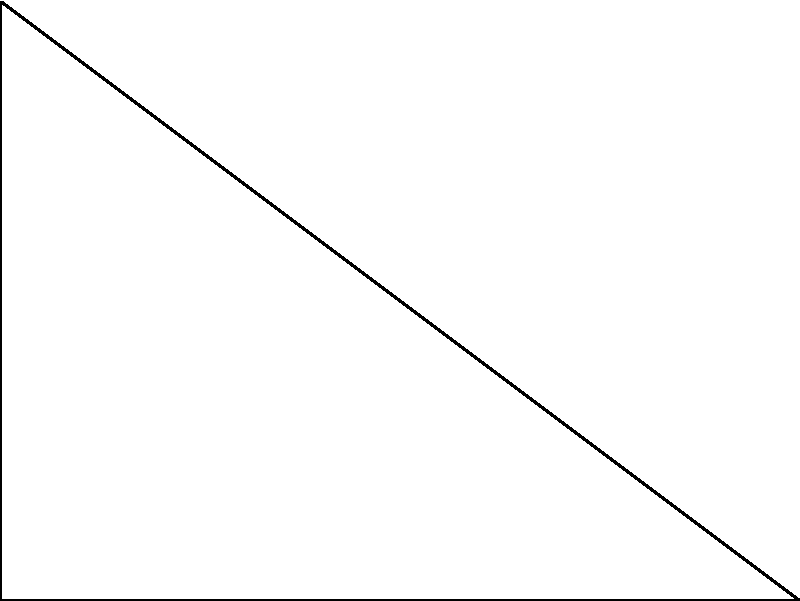During Hanukkah in Lisbon, Portugal (latitude 38.7° N), the solar elevation angle at noon is observed to be 28.5°. Given that the height of a building casts a shadow 15 meters long at this time, calculate the height of the building. To solve this problem, we'll use trigonometry and the given information about the solar elevation angle and shadow length. Let's approach this step-by-step:

1) First, let's identify the known variables:
   - Solar elevation angle (θ) = 28.5°
   - Shadow length (L) = 15 meters
   - We need to find the height of the building (H)

2) In the right-angled triangle formed by the building, its shadow, and the sun's rays:
   - The shadow length forms the adjacent side to the angle θ
   - The building height forms the opposite side to the angle θ

3) We can use the tangent trigonometric function, which is defined as:

   $$ \tan(\theta) = \frac{\text{opposite}}{\text{adjacent}} = \frac{\text{height}}{\text{shadow length}} $$

4) Substituting our known values:

   $$ \tan(28.5°) = \frac{H}{15} $$

5) To solve for H, multiply both sides by 15:

   $$ 15 \cdot \tan(28.5°) = H $$

6) Now we can calculate:
   $$ H = 15 \cdot \tan(28.5°) $$
   $$ H ≈ 15 \cdot 0.5423 $$
   $$ H ≈ 8.1345 \text{ meters} $$

7) Rounding to two decimal places for practical purposes:
   $$ H ≈ 8.13 \text{ meters} $$

This calculation takes into account the specific solar elevation angle during Hanukkah in Lisbon, demonstrating the intersection of Jewish tradition, Portuguese location, and mathematical principles.
Answer: 8.13 meters 